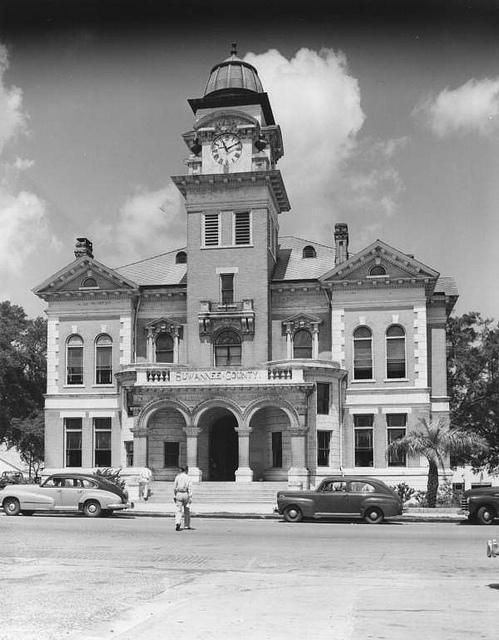How many staircases lead to the porch?
Give a very brief answer. 1. How many glass panels does the window on the top of the right side of the church have?
Give a very brief answer. 2. How many cars are in the photo?
Give a very brief answer. 2. 